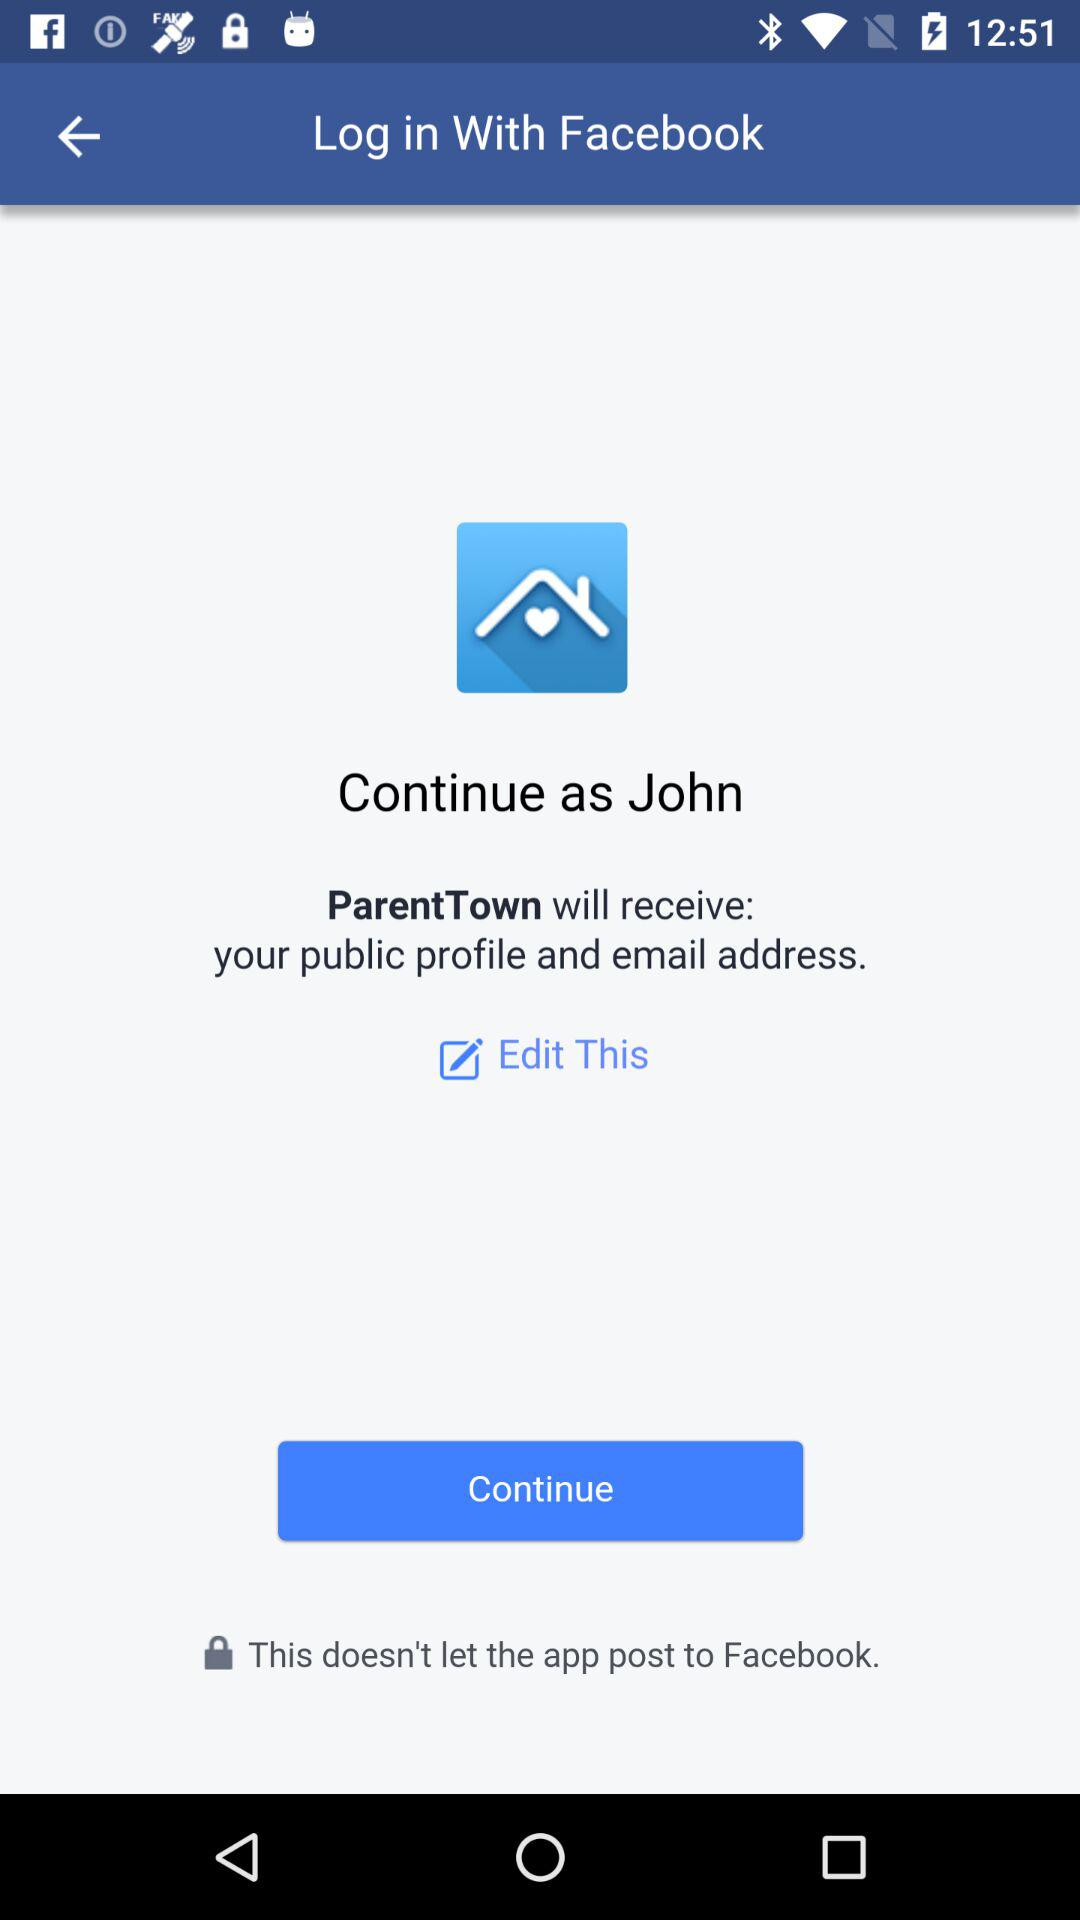What applications can be used to log in to a profile? The application that can be used to log in is "Facebook". 